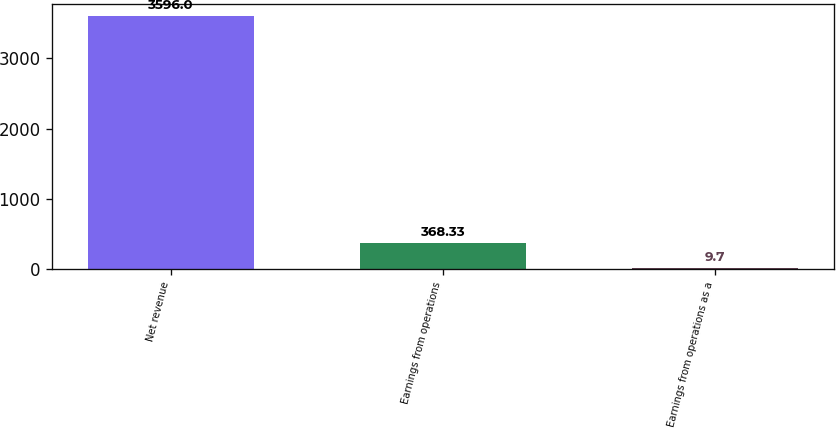<chart> <loc_0><loc_0><loc_500><loc_500><bar_chart><fcel>Net revenue<fcel>Earnings from operations<fcel>Earnings from operations as a<nl><fcel>3596<fcel>368.33<fcel>9.7<nl></chart> 